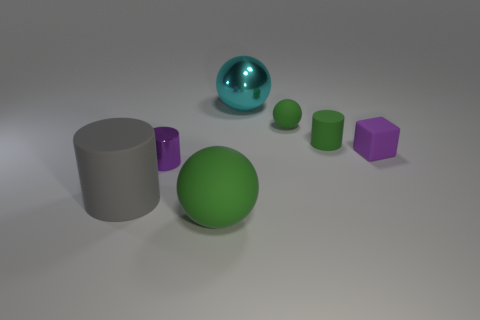Subtract all metallic balls. How many balls are left? 2 Subtract all gray cylinders. How many cylinders are left? 2 Add 2 big rubber objects. How many objects exist? 9 Subtract all cyan blocks. How many green balls are left? 2 Subtract 1 balls. How many balls are left? 2 Subtract 1 purple cylinders. How many objects are left? 6 Subtract all spheres. How many objects are left? 4 Subtract all gray cylinders. Subtract all brown spheres. How many cylinders are left? 2 Subtract all cyan things. Subtract all large gray matte objects. How many objects are left? 5 Add 1 small green things. How many small green things are left? 3 